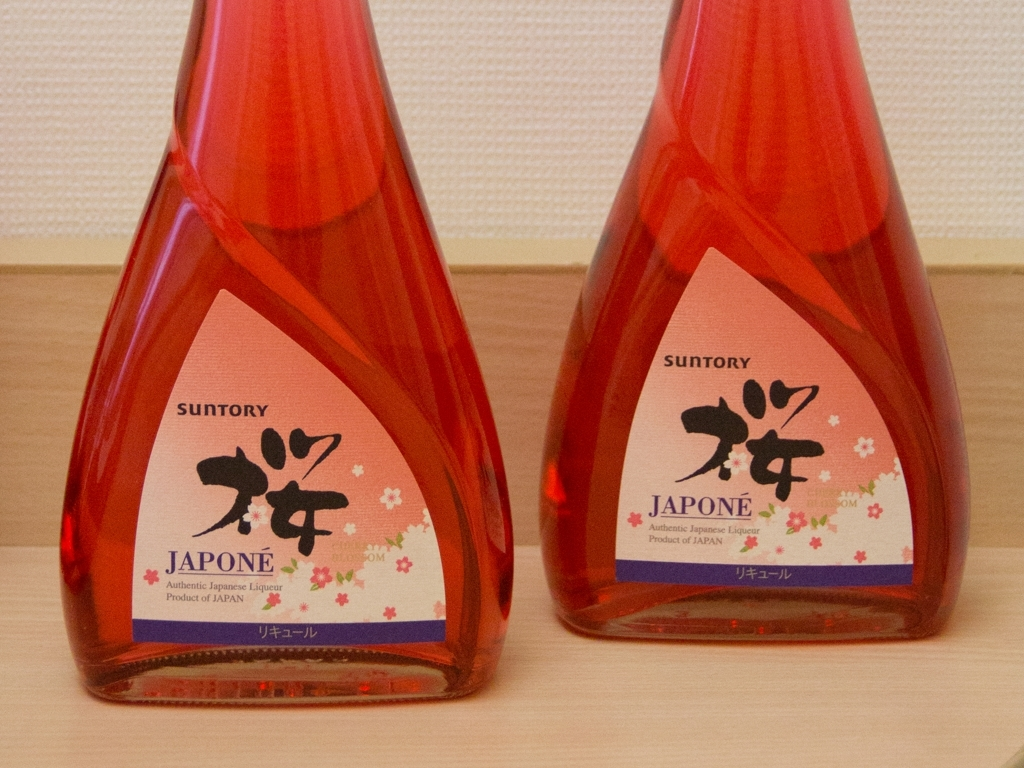Can you tell me what kind of product is shown in the image? The image displays two red bottles with labels indicating that they contain 'JAPONE Authentic Japanese Liqueur,' which is a type of alcoholic beverage produced in Japan. How might this liqueur be enjoyed traditionally? Japanese liqueurs like the one shown can be enjoyed in various ways, such as sipped neat, on the rocks, or as part of a cocktail. They might also be paired with traditional Japanese cuisine to complement the flavors of the dishes. 